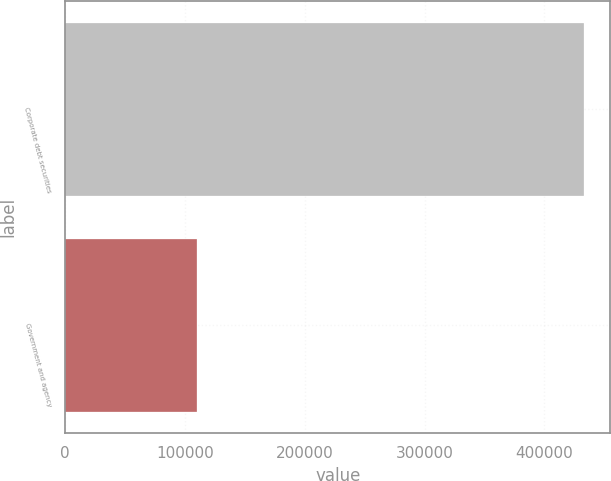<chart> <loc_0><loc_0><loc_500><loc_500><bar_chart><fcel>Corporate debt securities<fcel>Government and agency<nl><fcel>433192<fcel>109652<nl></chart> 